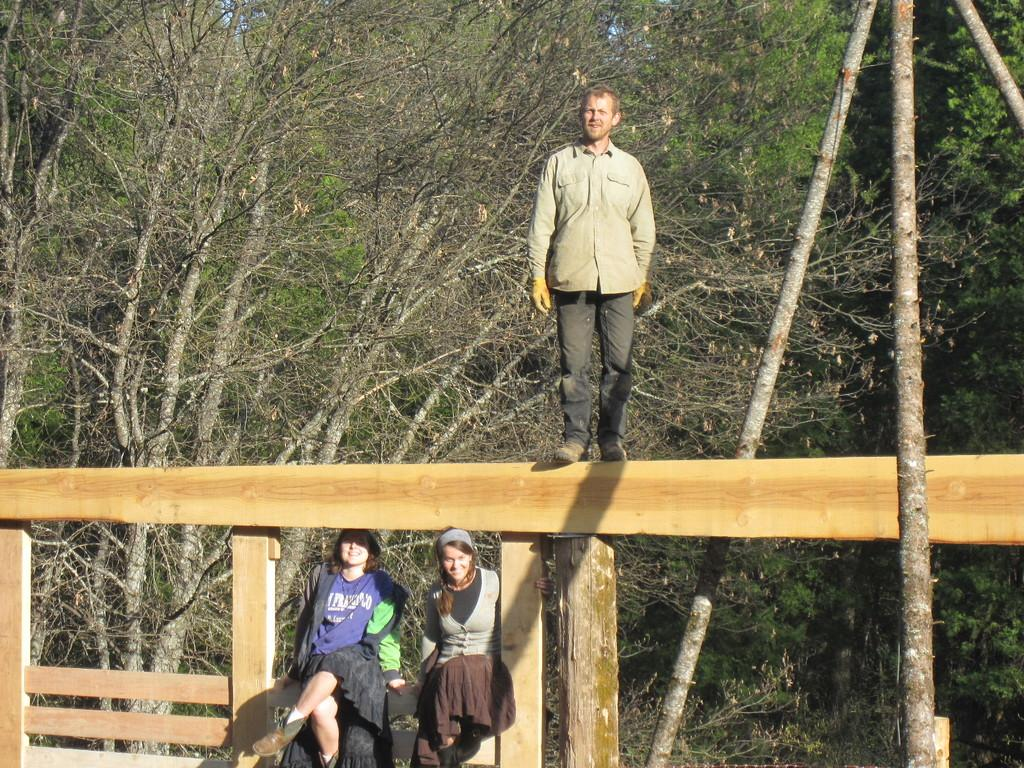What are the people in the image doing? The people in the image are sitting. Can you describe the person standing in the image? There is a person standing on a wooden fence. What objects can be seen in the image besides the people? Wooden sticks are visible in the image. What can be seen in the background of the image? There are trees in the background of the image. What type of trouble is the writer facing in the image? There is no writer or any indication of trouble in the image. 